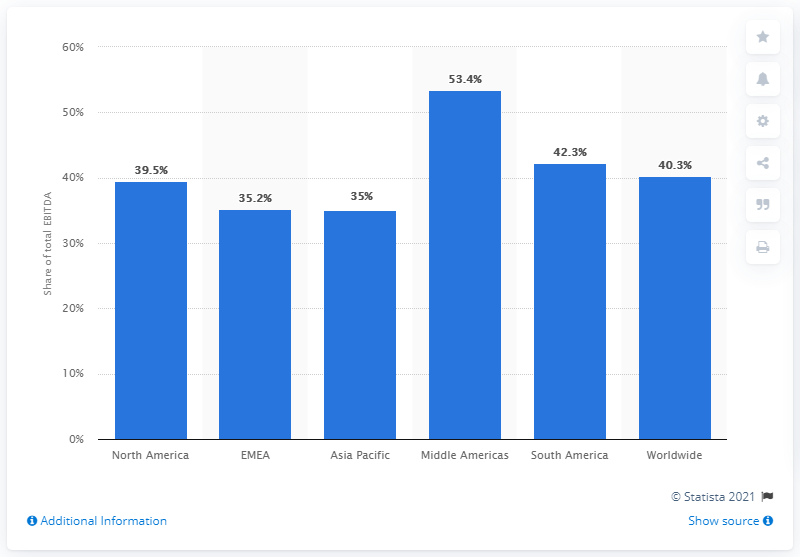Highlight a few significant elements in this photo. In 2020, Anheuser-Busch InBev's total EBITDA in North America was 39.5% of their total EBITDA. In the Middle Americas region, the share of total EBITDA is greater than the average share of total EBITDA across all regions. The middle American bar value is over 50%. 